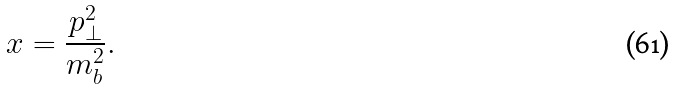<formula> <loc_0><loc_0><loc_500><loc_500>x = \frac { p ^ { 2 } _ { \perp } } { m ^ { 2 } _ { b } } .</formula> 